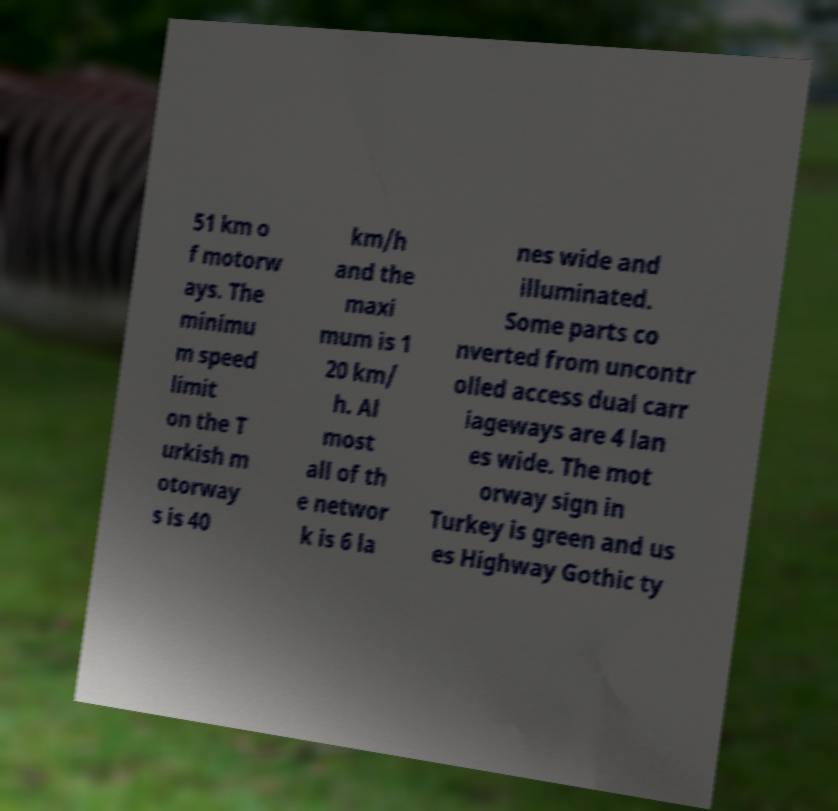Could you extract and type out the text from this image? 51 km o f motorw ays. The minimu m speed limit on the T urkish m otorway s is 40 km/h and the maxi mum is 1 20 km/ h. Al most all of th e networ k is 6 la nes wide and illuminated. Some parts co nverted from uncontr olled access dual carr iageways are 4 lan es wide. The mot orway sign in Turkey is green and us es Highway Gothic ty 